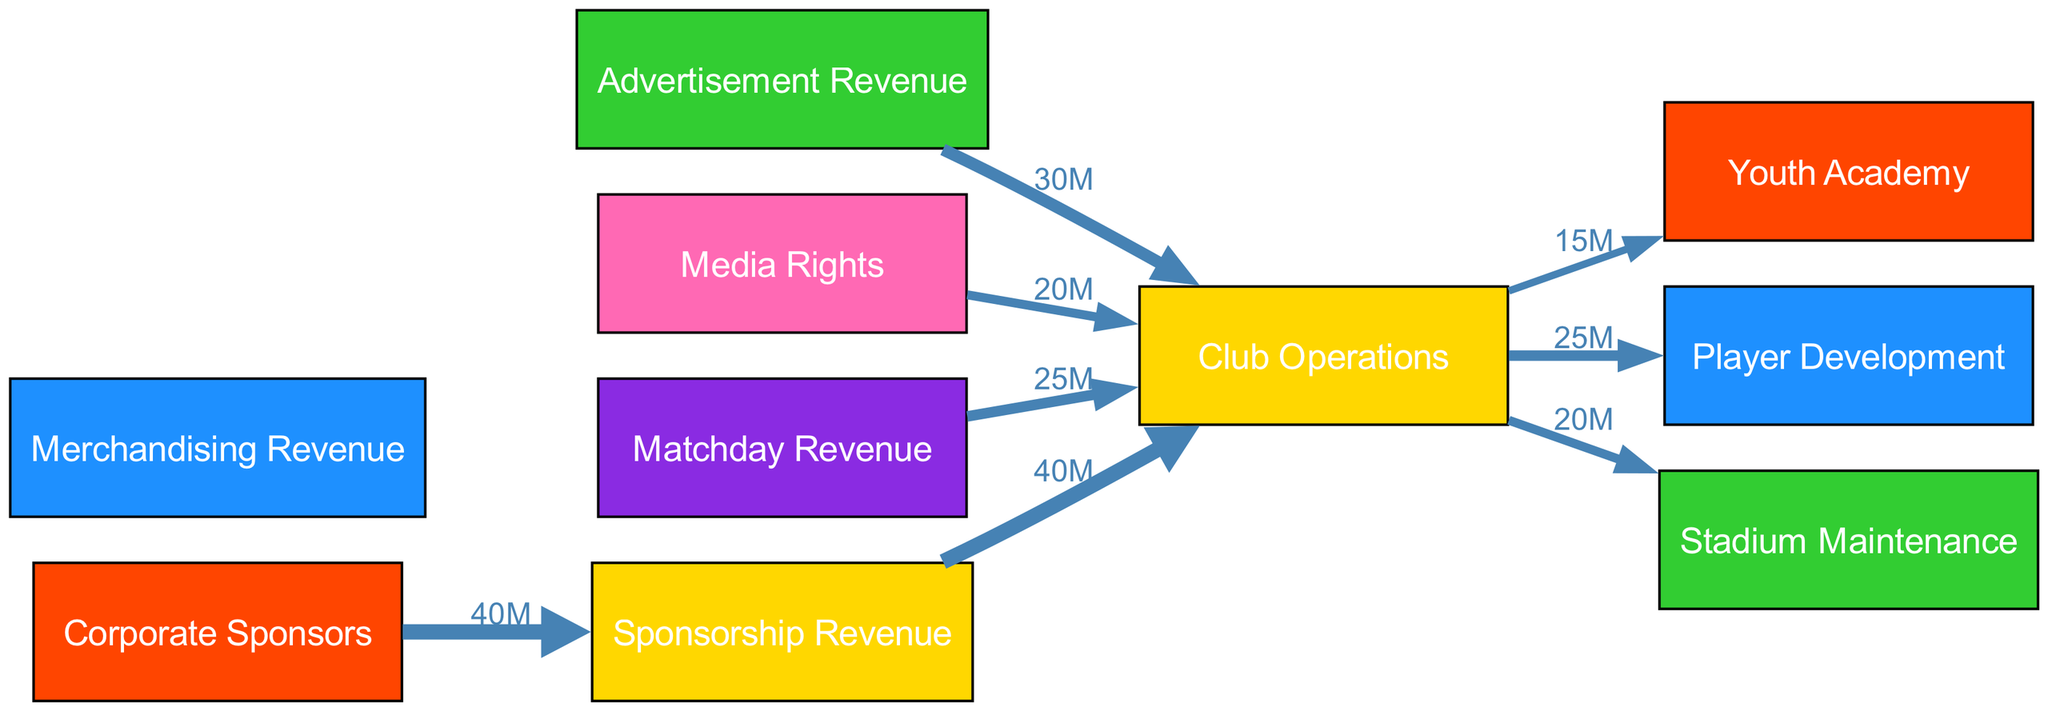What is the total value of Sponsorship Revenue? The diagram indicates that Corporate Sponsors contribute 40 million to Sponsorship Revenue, and this is the only source mentioned. Therefore, the total value is simply the 40 million from Corporate Sponsors.
Answer: 40 million What is the value of Advertisement Revenue flowing to Club Operations? According to the diagram, Advertisement Revenue directly connects to Club Operations with a value of 30 million, meaning that this amount flows from Advertisement Revenue to Club Operations.
Answer: 30 million How many nodes are present in the diagram? The diagram showcases a total of 10 distinct nodes, including both revenue sources and operational categories. By counting each labeled box, we confirm the total is 10.
Answer: 10 Which revenue source contributes the least to Club Operations? From the connections to Club Operations, the listed flows are Advertisement Revenue (30 million), Media Rights (20 million), Matchday Revenue (25 million), and Sponsorship Revenue (40 million). Media Rights provide the least contribution at 20 million.
Answer: 20 million What percentage of Club Operations revenue comes from Sponsorship Revenue? Sponsorship Revenue contributes 40 million to Club Operations, while the total revenue flowing into Club Operations from all sources counts up to 145 million (40 + 30 + 20 + 25). To find the percentage, we calculate (40/145) * 100, which equals approximately 27.59%.
Answer: 27.59% How much flow goes from Club Operations to Youth Academy? The diagram shows a flow from Club Operations to Youth Academy valued at 15 million, clearly indicated in the outgoing edges from Club Operations.
Answer: 15 million What is the total amount directed to Stadium Maintenance? The flow of funds directly from Club Operations to Stadium Maintenance is explicitly stated as 20 million, making that the value dedicated to maintaining the stadium.
Answer: 20 million Which department receives the highest funding from Club Operations? The edges indicate that Club Operations allocates 25 million to Player Development, which is higher than the allocations to Youth Academy (15 million) and Stadium Maintenance (20 million). Therefore, Player Development receives the highest funding from Club Operations.
Answer: Player Development What is the total revenue contribution to Club Operations from all sources combined? By adding the values from each revenue source that contributes to Club Operations, we have Sponsorship Revenue (40 million), Advertisement Revenue (30 million), Media Rights (20 million), and Matchday Revenue (25 million), leading to a total of 115 million flowing into Club Operations.
Answer: 115 million 